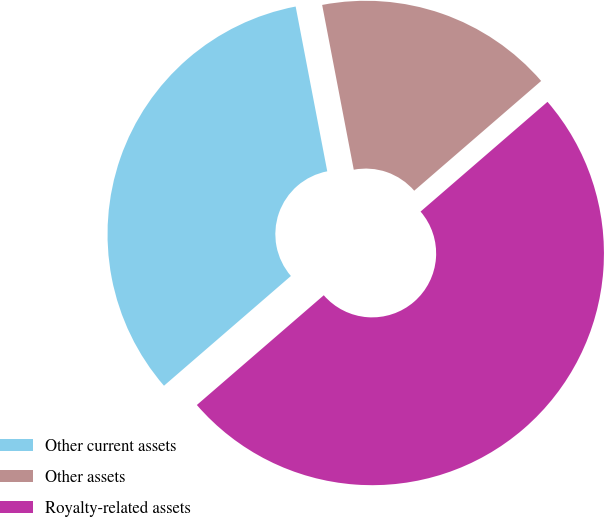<chart> <loc_0><loc_0><loc_500><loc_500><pie_chart><fcel>Other current assets<fcel>Other assets<fcel>Royalty-related assets<nl><fcel>33.33%<fcel>16.67%<fcel>50.0%<nl></chart> 